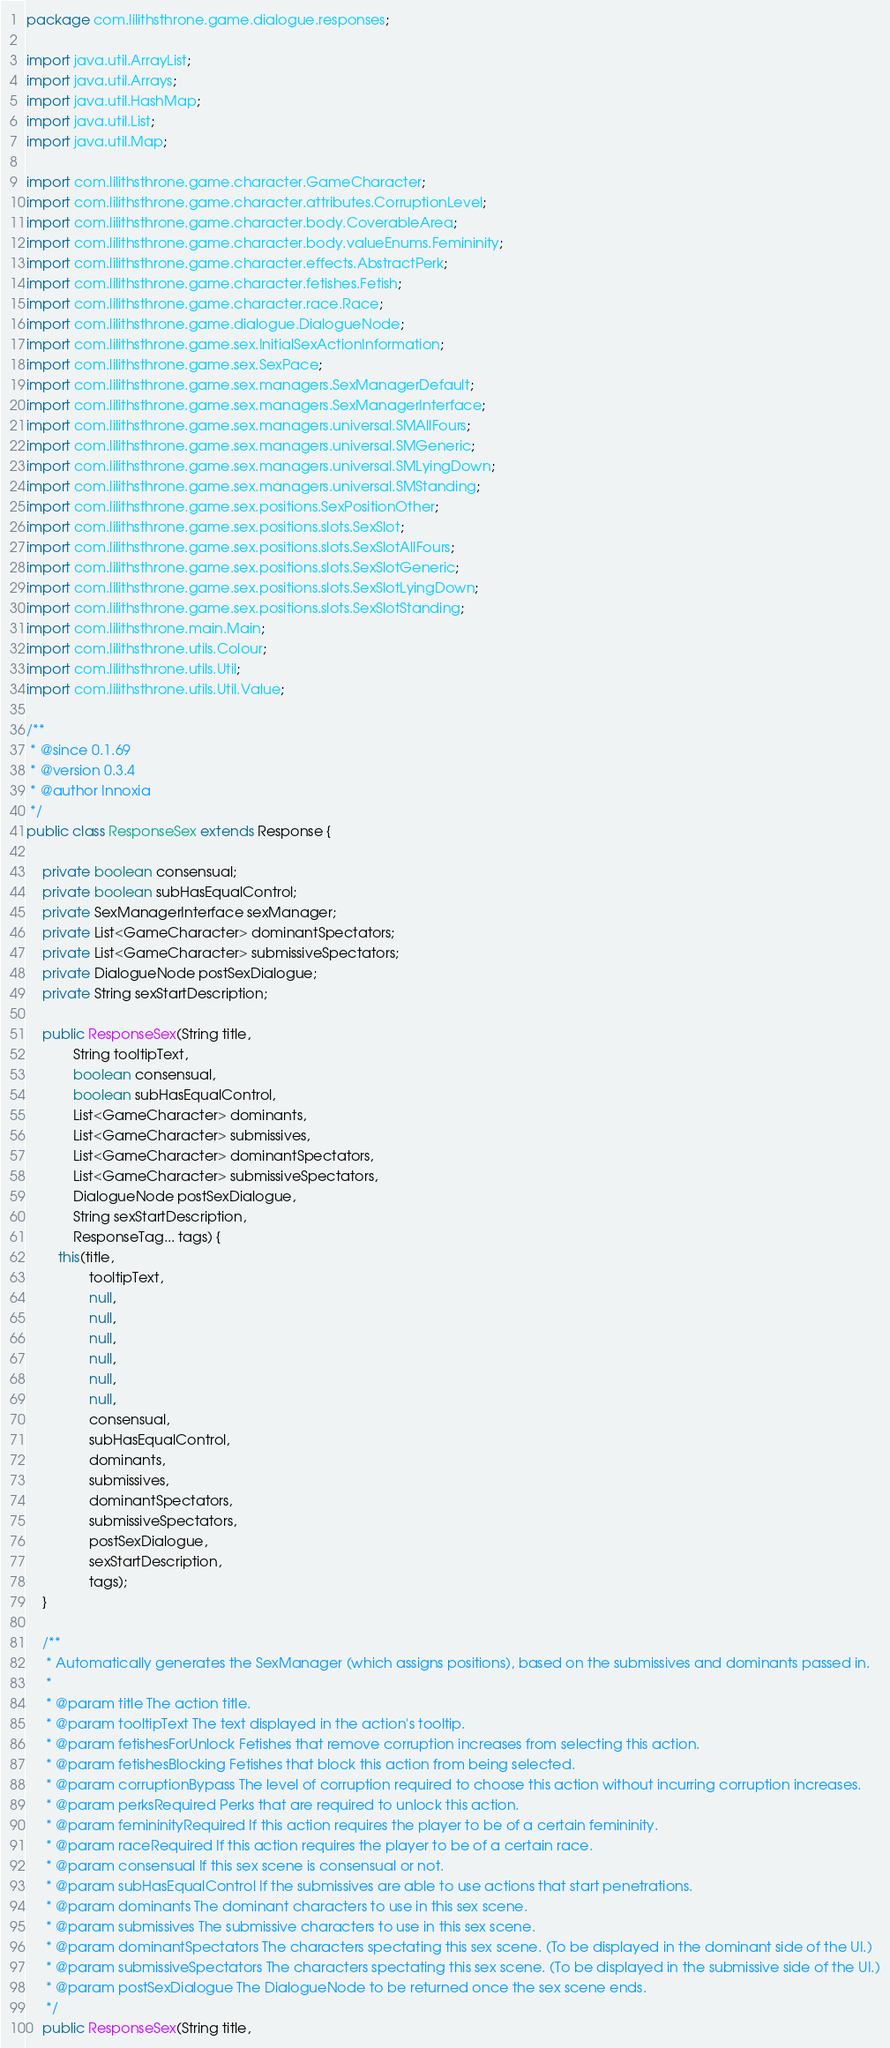Convert code to text. <code><loc_0><loc_0><loc_500><loc_500><_Java_>package com.lilithsthrone.game.dialogue.responses;

import java.util.ArrayList;
import java.util.Arrays;
import java.util.HashMap;
import java.util.List;
import java.util.Map;

import com.lilithsthrone.game.character.GameCharacter;
import com.lilithsthrone.game.character.attributes.CorruptionLevel;
import com.lilithsthrone.game.character.body.CoverableArea;
import com.lilithsthrone.game.character.body.valueEnums.Femininity;
import com.lilithsthrone.game.character.effects.AbstractPerk;
import com.lilithsthrone.game.character.fetishes.Fetish;
import com.lilithsthrone.game.character.race.Race;
import com.lilithsthrone.game.dialogue.DialogueNode;
import com.lilithsthrone.game.sex.InitialSexActionInformation;
import com.lilithsthrone.game.sex.SexPace;
import com.lilithsthrone.game.sex.managers.SexManagerDefault;
import com.lilithsthrone.game.sex.managers.SexManagerInterface;
import com.lilithsthrone.game.sex.managers.universal.SMAllFours;
import com.lilithsthrone.game.sex.managers.universal.SMGeneric;
import com.lilithsthrone.game.sex.managers.universal.SMLyingDown;
import com.lilithsthrone.game.sex.managers.universal.SMStanding;
import com.lilithsthrone.game.sex.positions.SexPositionOther;
import com.lilithsthrone.game.sex.positions.slots.SexSlot;
import com.lilithsthrone.game.sex.positions.slots.SexSlotAllFours;
import com.lilithsthrone.game.sex.positions.slots.SexSlotGeneric;
import com.lilithsthrone.game.sex.positions.slots.SexSlotLyingDown;
import com.lilithsthrone.game.sex.positions.slots.SexSlotStanding;
import com.lilithsthrone.main.Main;
import com.lilithsthrone.utils.Colour;
import com.lilithsthrone.utils.Util;
import com.lilithsthrone.utils.Util.Value;

/**
 * @since 0.1.69
 * @version 0.3.4
 * @author Innoxia
 */
public class ResponseSex extends Response {
	
	private boolean consensual;
	private boolean subHasEqualControl;
	private SexManagerInterface sexManager;
	private List<GameCharacter> dominantSpectators;
	private List<GameCharacter> submissiveSpectators;
	private DialogueNode postSexDialogue;
	private String sexStartDescription;
	
	public ResponseSex(String title,
			String tooltipText,
			boolean consensual,
			boolean subHasEqualControl,
			List<GameCharacter> dominants,
			List<GameCharacter> submissives,
			List<GameCharacter> dominantSpectators,
			List<GameCharacter> submissiveSpectators,
			DialogueNode postSexDialogue,
			String sexStartDescription,
			ResponseTag... tags) {
		this(title,
				tooltipText,
				null,
				null,
				null,
				null,
				null,
				null,
				consensual,
				subHasEqualControl,
				dominants,
				submissives,
				dominantSpectators,
				submissiveSpectators,
				postSexDialogue,
				sexStartDescription,
				tags);
	}
	
	/**
	 * Automatically generates the SexManager (which assigns positions), based on the submissives and dominants passed in.
	 * 
	 * @param title The action title.
	 * @param tooltipText The text displayed in the action's tooltip.
	 * @param fetishesForUnlock Fetishes that remove corruption increases from selecting this action.
	 * @param fetishesBlocking Fetishes that block this action from being selected.
	 * @param corruptionBypass The level of corruption required to choose this action without incurring corruption increases.
	 * @param perksRequired Perks that are required to unlock this action.
	 * @param femininityRequired If this action requires the player to be of a certain femininity.
	 * @param raceRequired If this action requires the player to be of a certain race.
	 * @param consensual If this sex scene is consensual or not.
	 * @param subHasEqualControl If the submissives are able to use actions that start penetrations.
	 * @param dominants The dominant characters to use in this sex scene.
	 * @param submissives The submissive characters to use in this sex scene.
	 * @param dominantSpectators The characters spectating this sex scene. (To be displayed in the dominant side of the UI.)
	 * @param submissiveSpectators The characters spectating this sex scene. (To be displayed in the submissive side of the UI.)
	 * @param postSexDialogue The DialogueNode to be returned once the sex scene ends.
	 */
	public ResponseSex(String title,</code> 